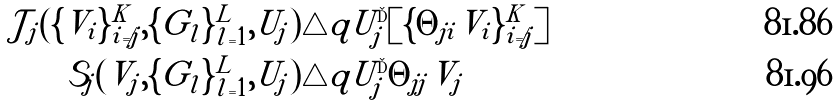<formula> <loc_0><loc_0><loc_500><loc_500>\mathcal { J } _ { j } ( \{ V _ { i } \} _ { i \neq j } ^ { K } , \{ G _ { l } \} _ { l = 1 } ^ { L } , U _ { j } ) & \triangle q U _ { j } ^ { \dag } [ \{ \Theta _ { j i } V _ { i } \} _ { i \neq j } ^ { K } ] \\ \mathcal { S } _ { j } ( V _ { j } , \{ G _ { l } \} _ { l = 1 } ^ { L } , U _ { j } ) & \triangle q U _ { j } ^ { \dag } \Theta _ { j j } V _ { j }</formula> 